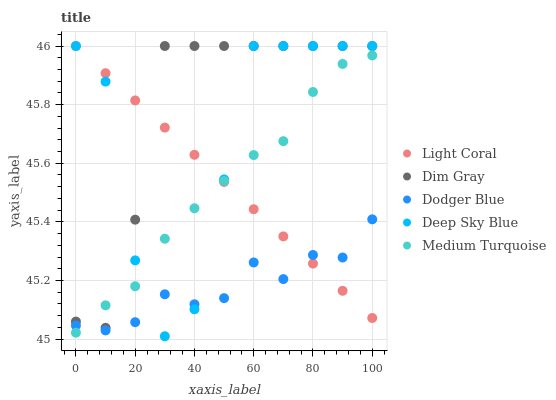Does Dodger Blue have the minimum area under the curve?
Answer yes or no. Yes. Does Dim Gray have the maximum area under the curve?
Answer yes or no. Yes. Does Dim Gray have the minimum area under the curve?
Answer yes or no. No. Does Dodger Blue have the maximum area under the curve?
Answer yes or no. No. Is Light Coral the smoothest?
Answer yes or no. Yes. Is Deep Sky Blue the roughest?
Answer yes or no. Yes. Is Dim Gray the smoothest?
Answer yes or no. No. Is Dim Gray the roughest?
Answer yes or no. No. Does Deep Sky Blue have the lowest value?
Answer yes or no. Yes. Does Dim Gray have the lowest value?
Answer yes or no. No. Does Deep Sky Blue have the highest value?
Answer yes or no. Yes. Does Dodger Blue have the highest value?
Answer yes or no. No. Is Dodger Blue less than Dim Gray?
Answer yes or no. Yes. Is Dim Gray greater than Dodger Blue?
Answer yes or no. Yes. Does Light Coral intersect Deep Sky Blue?
Answer yes or no. Yes. Is Light Coral less than Deep Sky Blue?
Answer yes or no. No. Is Light Coral greater than Deep Sky Blue?
Answer yes or no. No. Does Dodger Blue intersect Dim Gray?
Answer yes or no. No. 